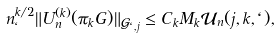<formula> <loc_0><loc_0><loc_500><loc_500>n _ { \ell } ^ { k / 2 } \| U _ { n } ^ { ( k ) } ( \pi _ { k } G ) \| _ { \mathcal { G } _ { \ell , j } } \leq C _ { k } M _ { k } \mathcal { U } _ { n } ( j , k , \ell ) ,</formula> 